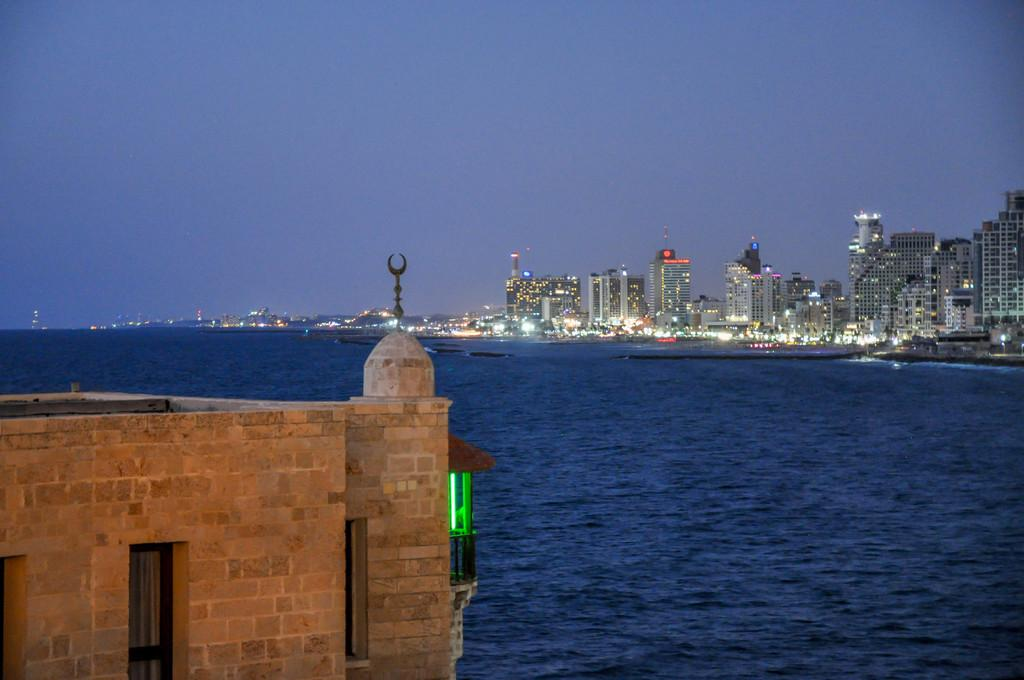What type of structures can be seen in the image? There are buildings in the image. What else is visible in the image besides the buildings? There are lights and water in the center of the image. What can be seen in the background of the image? There is sky visible in the background of the image. What type of jeans is the water wearing in the image? There are no jeans present in the image, as the water is not a person or an entity that can wear clothing. 